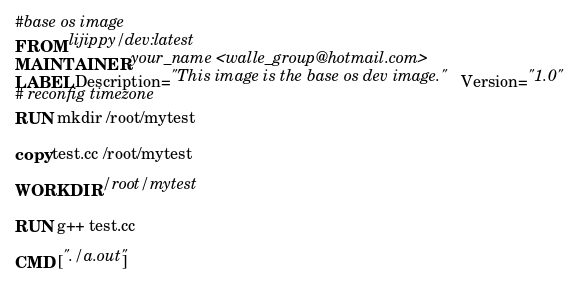Convert code to text. <code><loc_0><loc_0><loc_500><loc_500><_Dockerfile_>#base os image
FROM lijippy/dev:latest 
MAINTAINER your_name <walle_group@hotmail.com>
LABEL Description="This image is the base os dev image."  Version="1.0"
# reconfig timezone
RUN mkdir /root/mytest

copy test.cc /root/mytest

WORKDIR /root/mytest

RUN g++ test.cc

CMD ["./a.out"]


</code> 